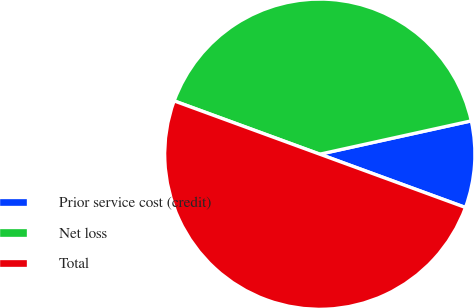<chart> <loc_0><loc_0><loc_500><loc_500><pie_chart><fcel>Prior service cost (credit)<fcel>Net loss<fcel>Total<nl><fcel>9.03%<fcel>40.97%<fcel>50.0%<nl></chart> 